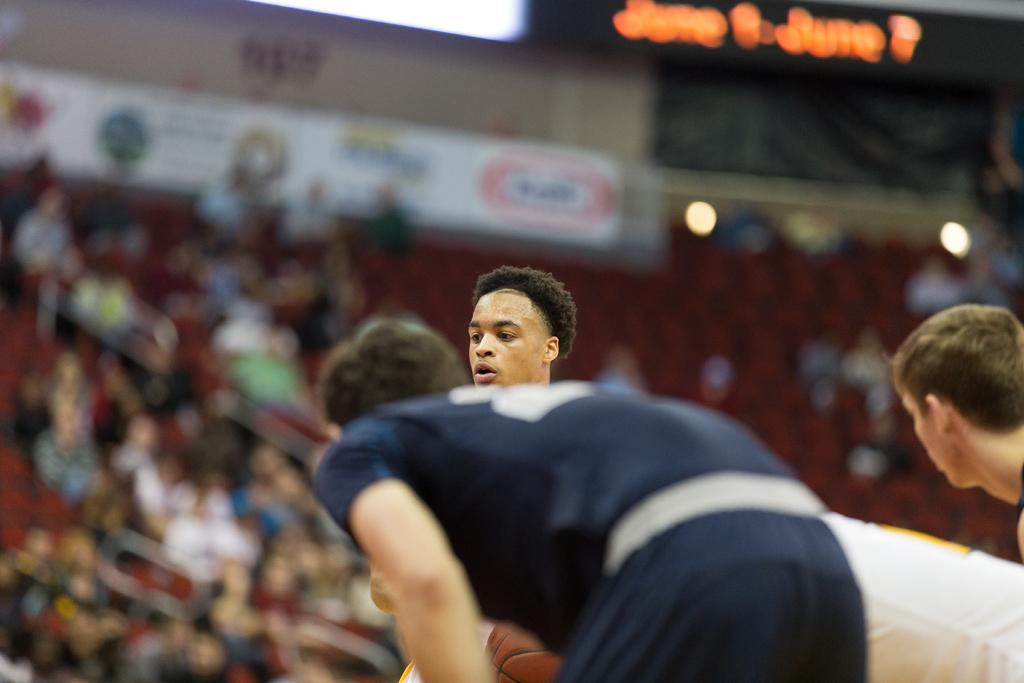How many people are in the image? There are three persons in the image. What can be observed about the background in the image? The background is blurred. What else is visible in the image besides the three persons? There is a crowd visible in the image. What can be seen in the image that might provide illumination? There are lights in the image. What type of signage is present in the image? There is a hoarding in the image. Can you describe the worm that is visible in the image? There is no worm present in the image. What is the digestion process of the worm in the image? There is no worm present in the image, so it is not possible to describe its digestion process. 